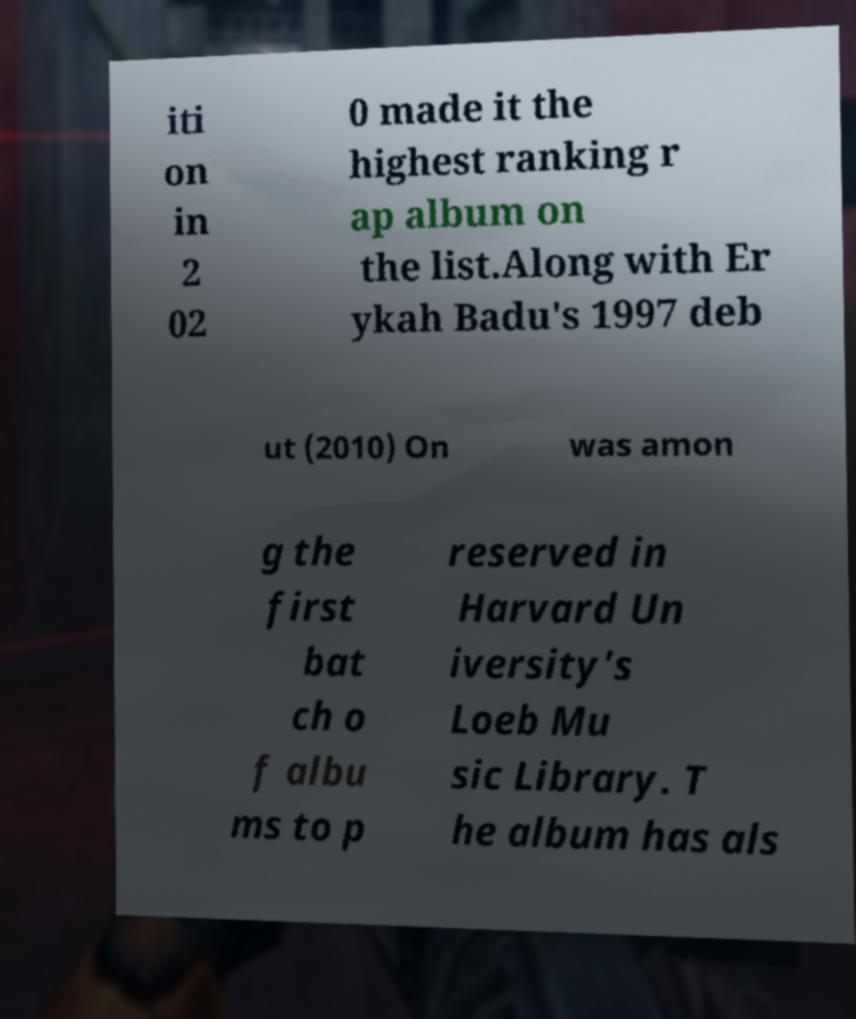Please read and relay the text visible in this image. What does it say? iti on in 2 02 0 made it the highest ranking r ap album on the list.Along with Er ykah Badu's 1997 deb ut (2010) On was amon g the first bat ch o f albu ms to p reserved in Harvard Un iversity's Loeb Mu sic Library. T he album has als 